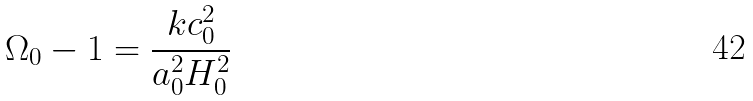Convert formula to latex. <formula><loc_0><loc_0><loc_500><loc_500>\Omega _ { 0 } - 1 = \frac { k c _ { 0 } ^ { 2 } } { a _ { 0 } ^ { 2 } H _ { 0 } ^ { 2 } }</formula> 